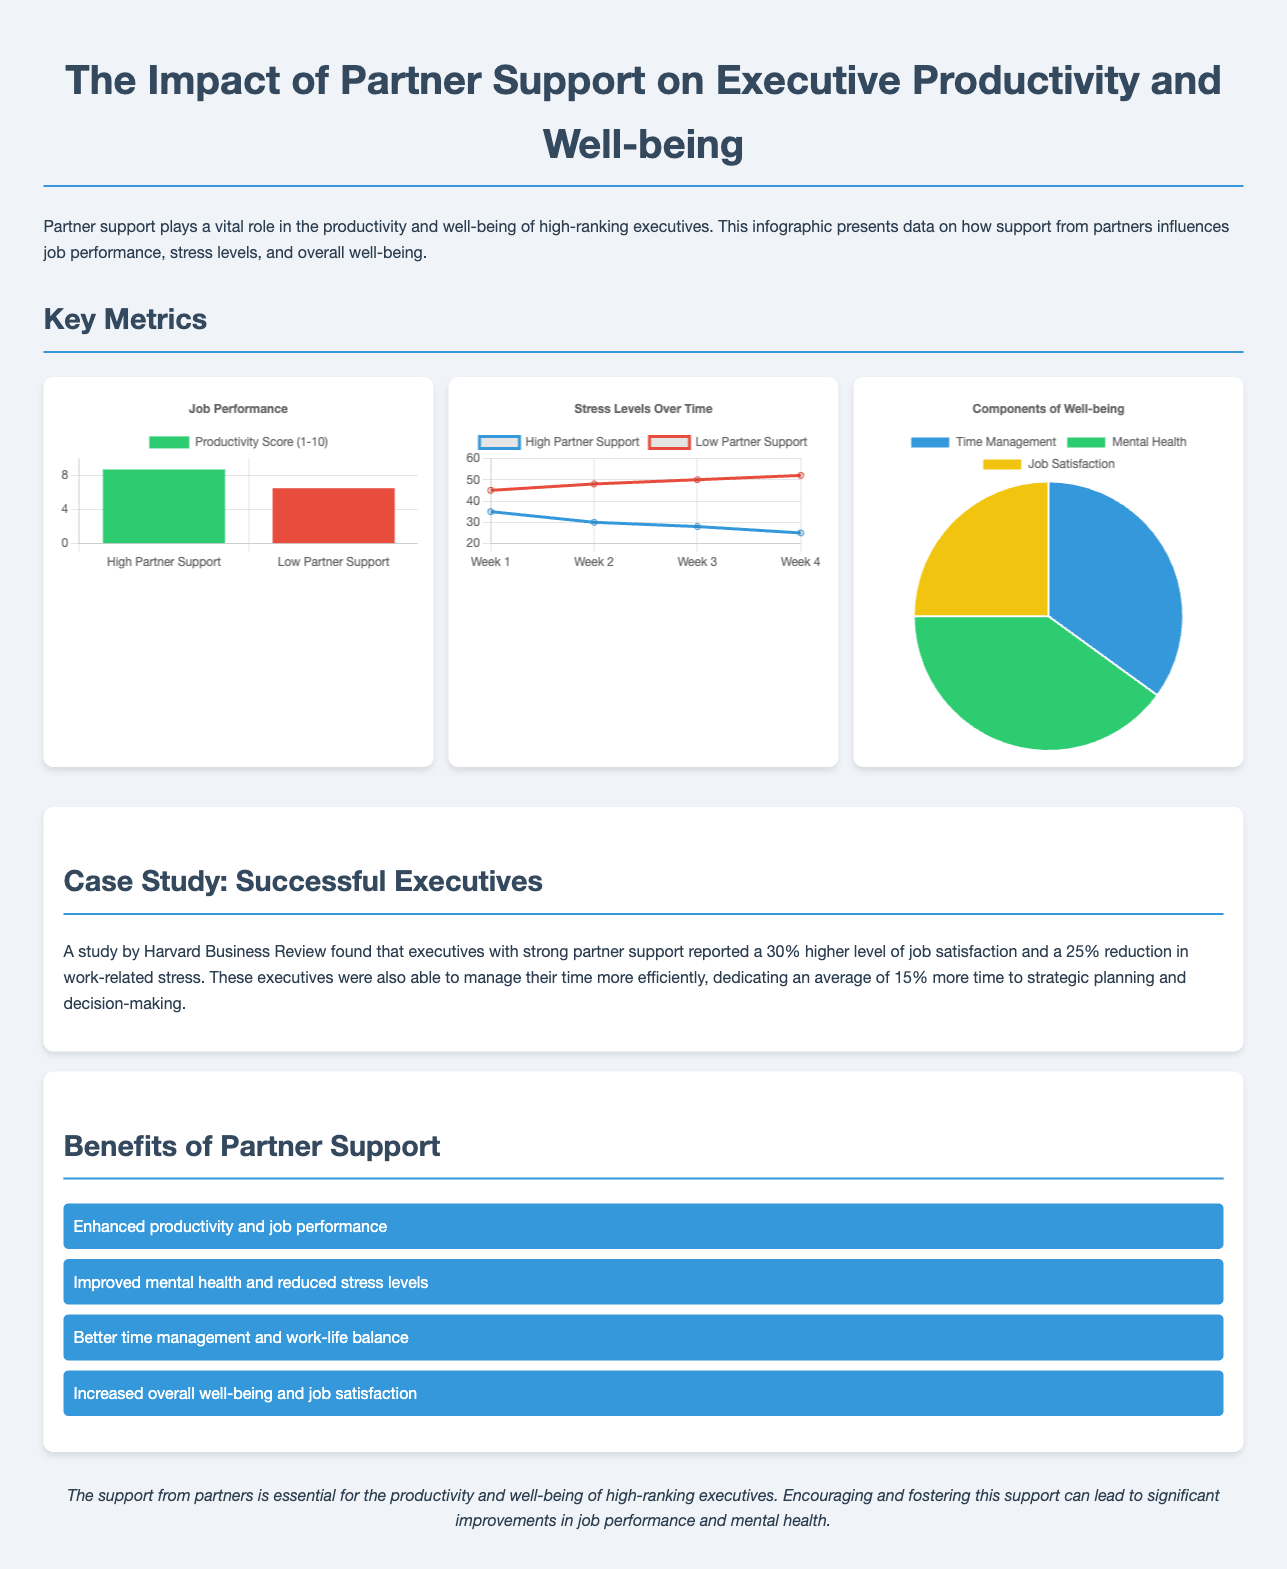What is the productivity score for high partner support? The productivity score for high partner support is indicated in the chart as 8.7.
Answer: 8.7 What percentage reduction in work-related stress is reported by executives with high partner support? The case study notes a 25% reduction in work-related stress for executives with strong partner support.
Answer: 25% Which color represents low partner support in the job performance chart? The job performance chart uses red to represent low partner support.
Answer: Red What are the three components of the well-being chart? The well-being chart displays time management, mental health, and job satisfaction as its components.
Answer: Time management, mental health, job satisfaction In which week do stress levels for high partner support drop to 25? According to the stress levels chart, stress levels for high partner support drop to 25 in week 4.
Answer: Week 4 How much more time do executives with strong partner support dedicate to strategic planning and decision-making? Executives with strong partner support dedicate an average of 15% more time to strategic planning and decision-making.
Answer: 15% What is the title of the infographic? The title of the infographic is presented at the top of the document.
Answer: The Impact of Partner Support on Executive Productivity and Well-being 